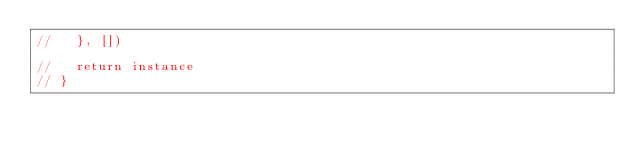Convert code to text. <code><loc_0><loc_0><loc_500><loc_500><_JavaScript_>//   }, [])

//   return instance
// }
</code> 